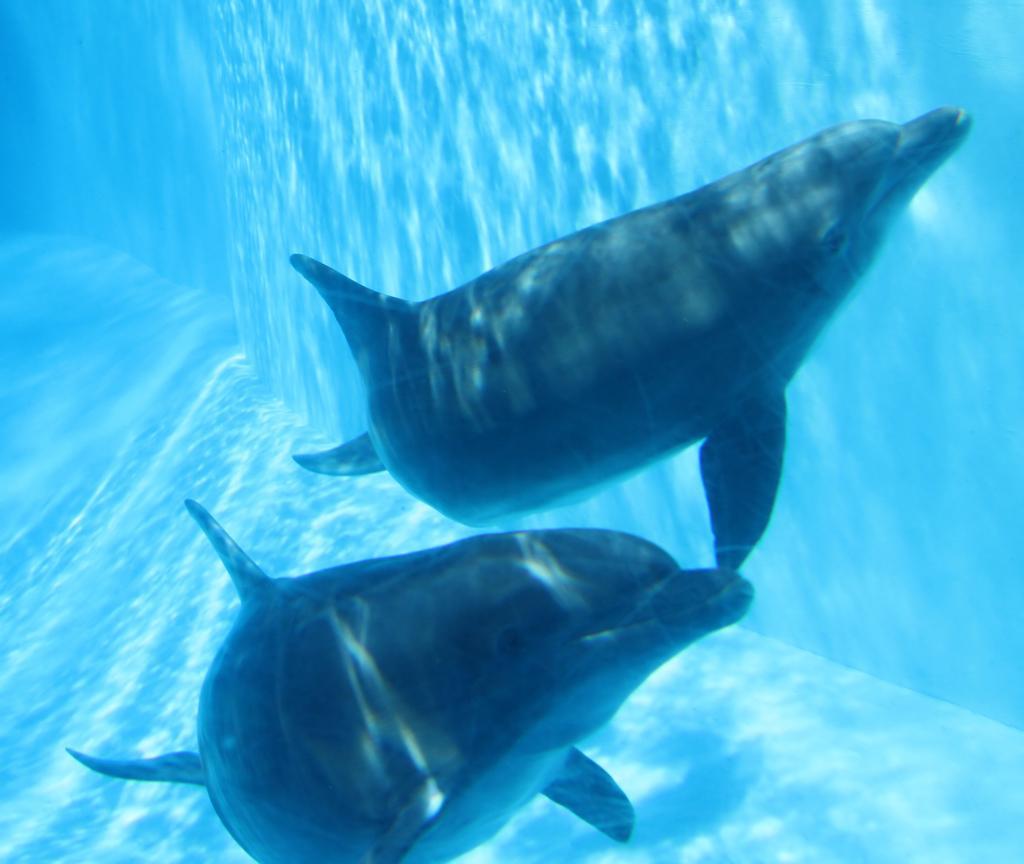Could you give a brief overview of what you see in this image? In this picture we can see aquatic animals in the water. 